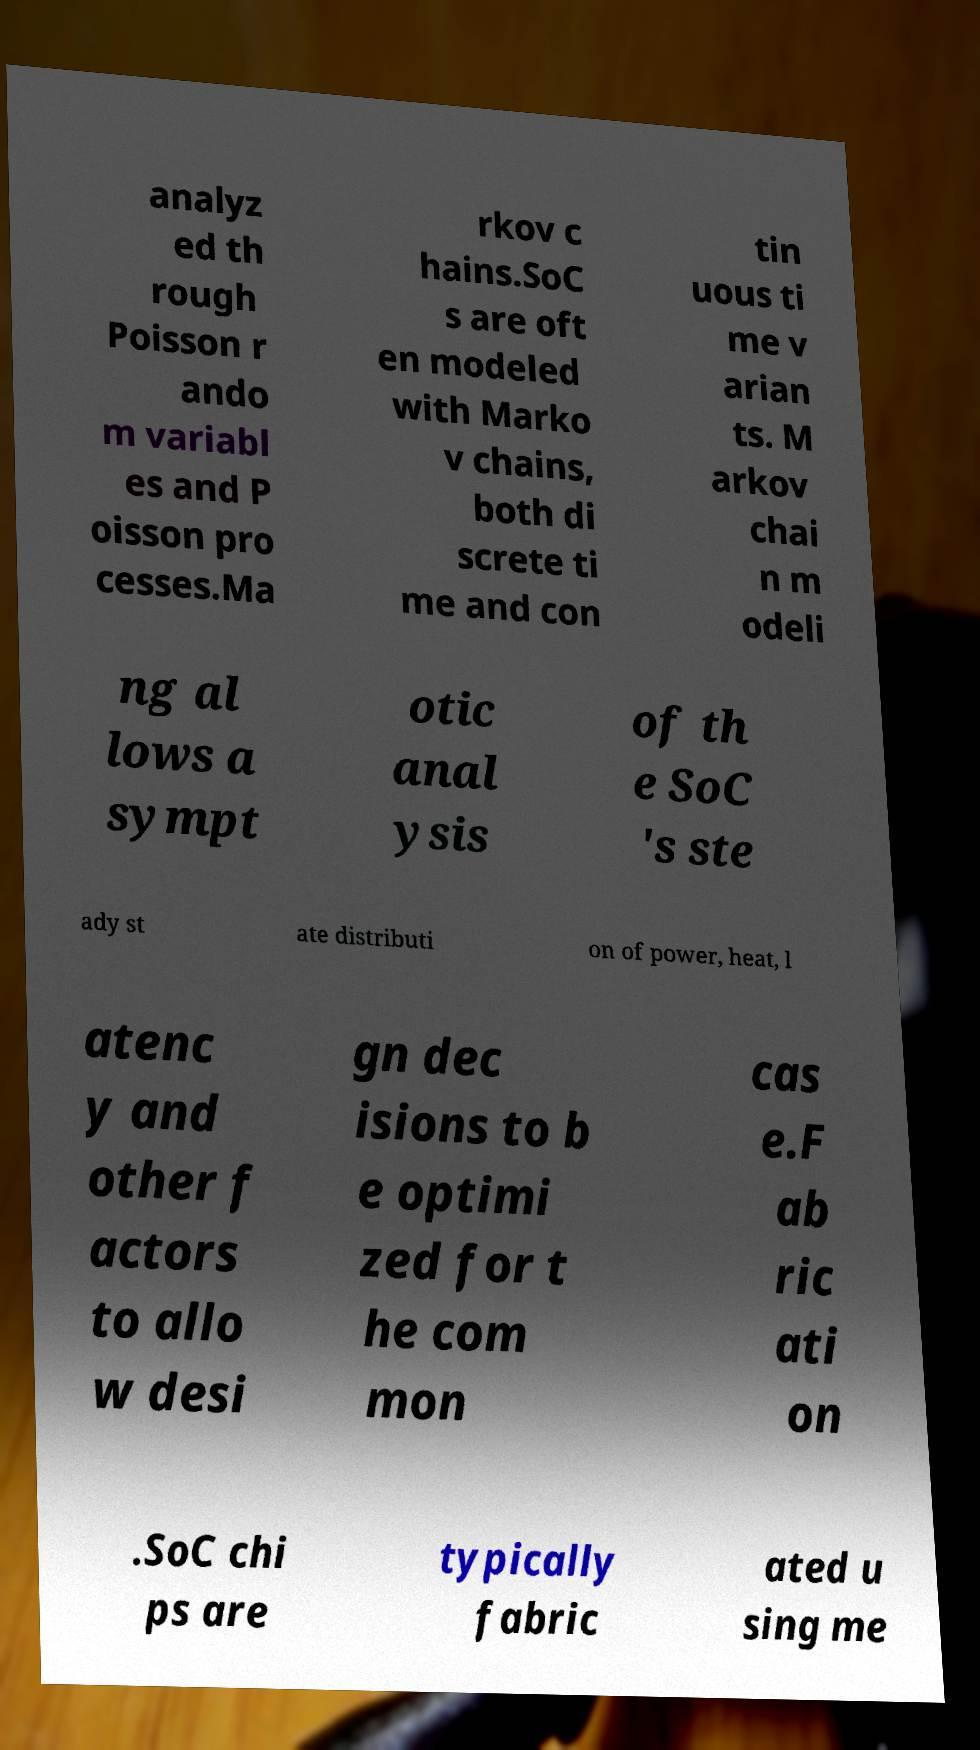Can you accurately transcribe the text from the provided image for me? analyz ed th rough Poisson r ando m variabl es and P oisson pro cesses.Ma rkov c hains.SoC s are oft en modeled with Marko v chains, both di screte ti me and con tin uous ti me v arian ts. M arkov chai n m odeli ng al lows a sympt otic anal ysis of th e SoC 's ste ady st ate distributi on of power, heat, l atenc y and other f actors to allo w desi gn dec isions to b e optimi zed for t he com mon cas e.F ab ric ati on .SoC chi ps are typically fabric ated u sing me 